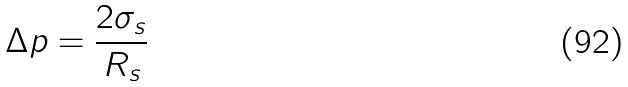<formula> <loc_0><loc_0><loc_500><loc_500>\Delta p = \frac { 2 \sigma _ { s } } { R _ { s } }</formula> 